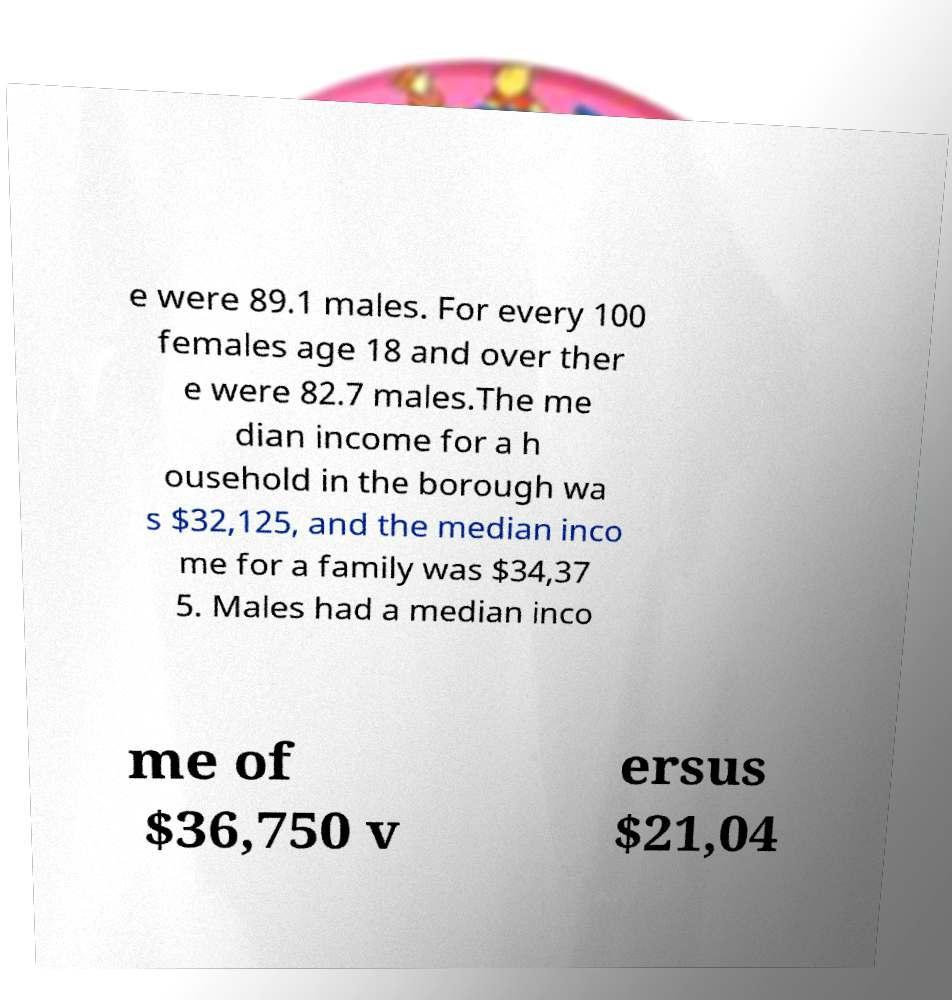Can you read and provide the text displayed in the image?This photo seems to have some interesting text. Can you extract and type it out for me? e were 89.1 males. For every 100 females age 18 and over ther e were 82.7 males.The me dian income for a h ousehold in the borough wa s $32,125, and the median inco me for a family was $34,37 5. Males had a median inco me of $36,750 v ersus $21,04 